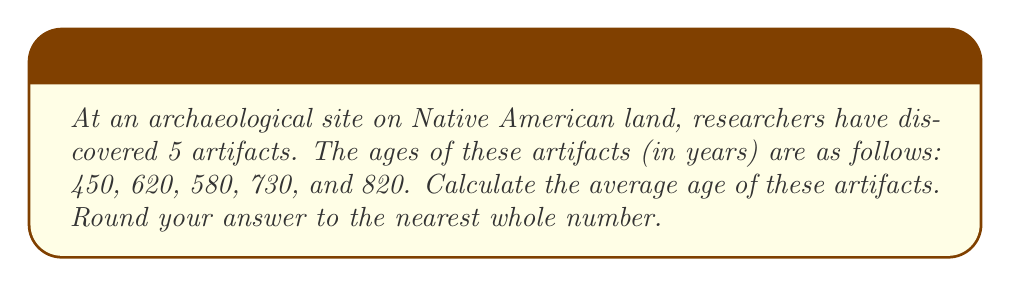Give your solution to this math problem. To solve this problem, we need to follow these steps:

1. Understand the formula for calculating the average (arithmetic mean):
   $$ \text{Average} = \frac{\text{Sum of all values}}{\text{Number of values}} $$

2. Sum up the ages of all artifacts:
   $$ 450 + 620 + 580 + 730 + 820 = 3200 \text{ years} $$

3. Count the number of artifacts:
   There are 5 artifacts in total.

4. Apply the average formula:
   $$ \text{Average age} = \frac{3200 \text{ years}}{5} = 640 \text{ years} $$

5. Round to the nearest whole number:
   The result is already a whole number, so no rounding is necessary.

This calculation gives us the average age of the artifacts found at the Native American archaeological site, providing valuable information about the time period these artifacts represent in Indigenous history.
Answer: $640$ years 